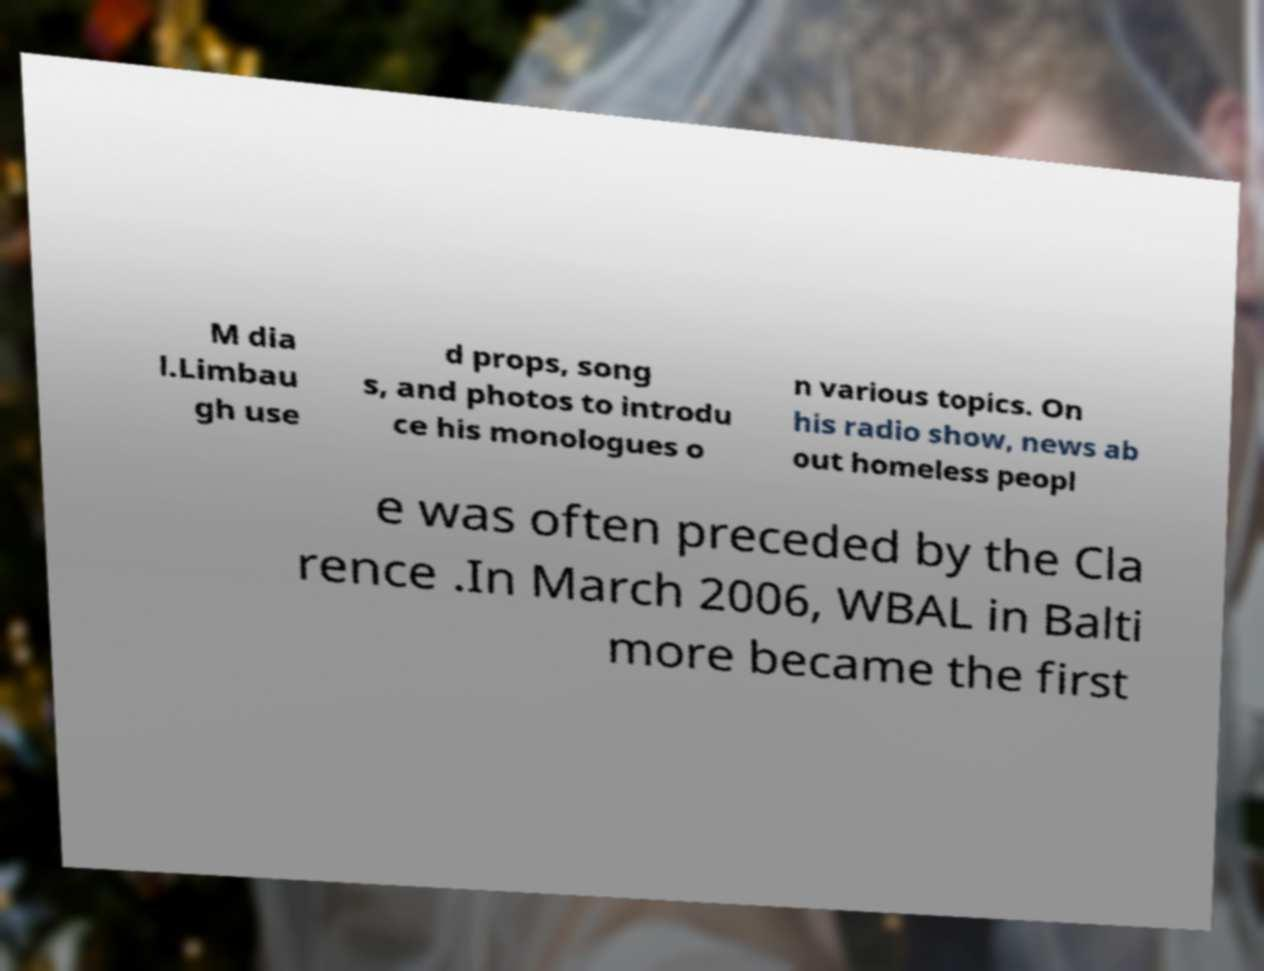For documentation purposes, I need the text within this image transcribed. Could you provide that? M dia l.Limbau gh use d props, song s, and photos to introdu ce his monologues o n various topics. On his radio show, news ab out homeless peopl e was often preceded by the Cla rence .In March 2006, WBAL in Balti more became the first 